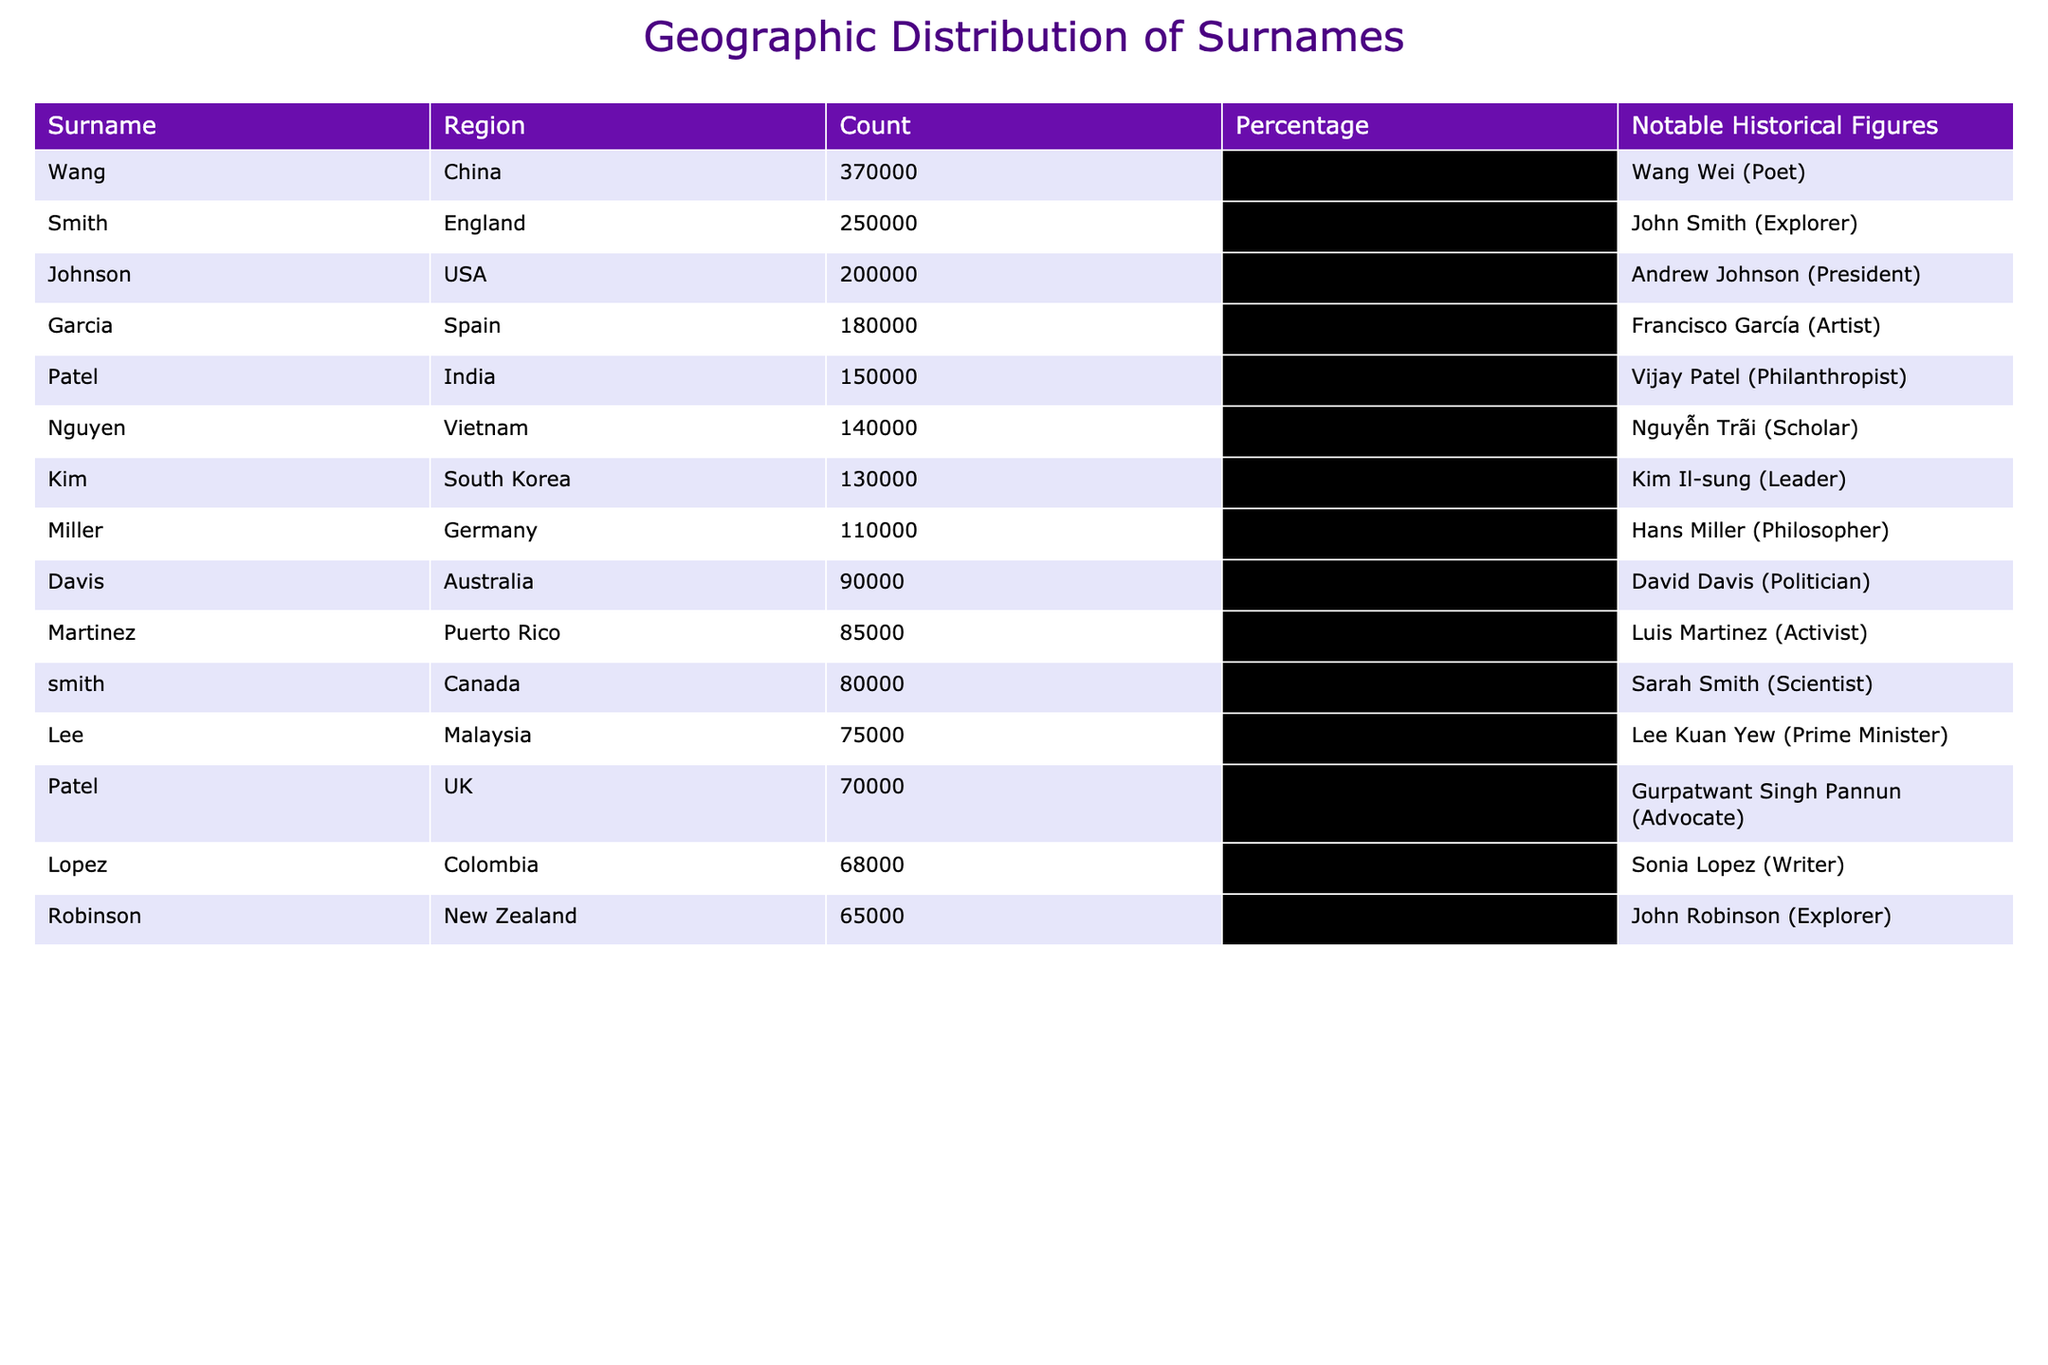What surname has the highest count in the table? The table shows the count of each surname. By scanning through the 'Count' column, 'Wang' has the highest count with 370,000.
Answer: Wang Which region has the lowest percentage of surnames represented? By examining the 'Percentage' column, the lowest percentage is for 'Davis' at 4.5%.
Answer: Australia Is 'Garcia' a more common surname in Spain or the USA? The table indicates that 'Garcia' has a count of 180,000 in Spain and there is no mention of it in the USA, confirming it is more common in Spain.
Answer: Yes, in Spain How many surnames have a count greater than 100,000? Reviewing the 'Count' column, there are 6 surnames: Smith, Johnson, Garcia, Patel, Nguyen, and Wang, all with counts exceeding 100,000.
Answer: 6 What is the total count of all surnames listed in the table? Adding all the counts together: 250000 + 200000 + 180000 + 150000 + 140000 + 130000 + 370000 + 110000 + 90000 + 85000 + 80000 + 75000 + 70000 + 68000 + 65000 = 1575000.
Answer: 1,575,000 Which surname is represented in both the USA and Canada? The table lists 'Smith' in both the USA and Canada, confirming its presence in both regions.
Answer: Smith What percentage of surnames in the table belong to regions outside Europe? The non-European surnames identified are Johnson, Garcia, Patel, Nguyen, Kim, Wang, Martinez, and Lopez. Counting these gives 8 surnames out of 15 total, which is (8/15)*100 = 53.3%.
Answer: 53.3% Is there a notable historical figure associated with the surname 'Nguyen'? The table confirms there is a notable historical figure, Nguyễn Trãi, associated with the surname 'Nguyen'.
Answer: Yes, Nguyễn Trãi What is the difference in percentage between the highest and lowest percentages in the table? The highest percentage is 18.2% for 'Wang' and the lowest is 4.2% for 'Martinez'. The difference is 18.2% - 4.2% = 14%.
Answer: 14% How many surnames have a notable historical figure listed? Scanning the 'Notable Historical Figures' column, all surnames listed have a notable figure associated with them, totaling 15 surnames.
Answer: 15 